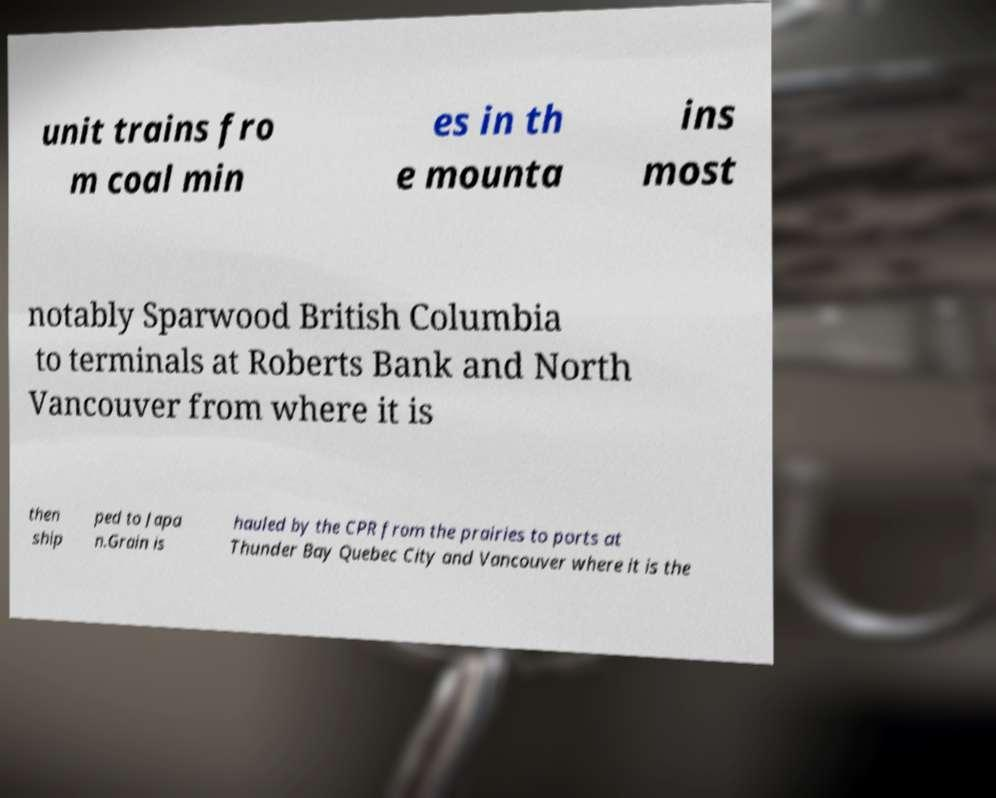There's text embedded in this image that I need extracted. Can you transcribe it verbatim? unit trains fro m coal min es in th e mounta ins most notably Sparwood British Columbia to terminals at Roberts Bank and North Vancouver from where it is then ship ped to Japa n.Grain is hauled by the CPR from the prairies to ports at Thunder Bay Quebec City and Vancouver where it is the 